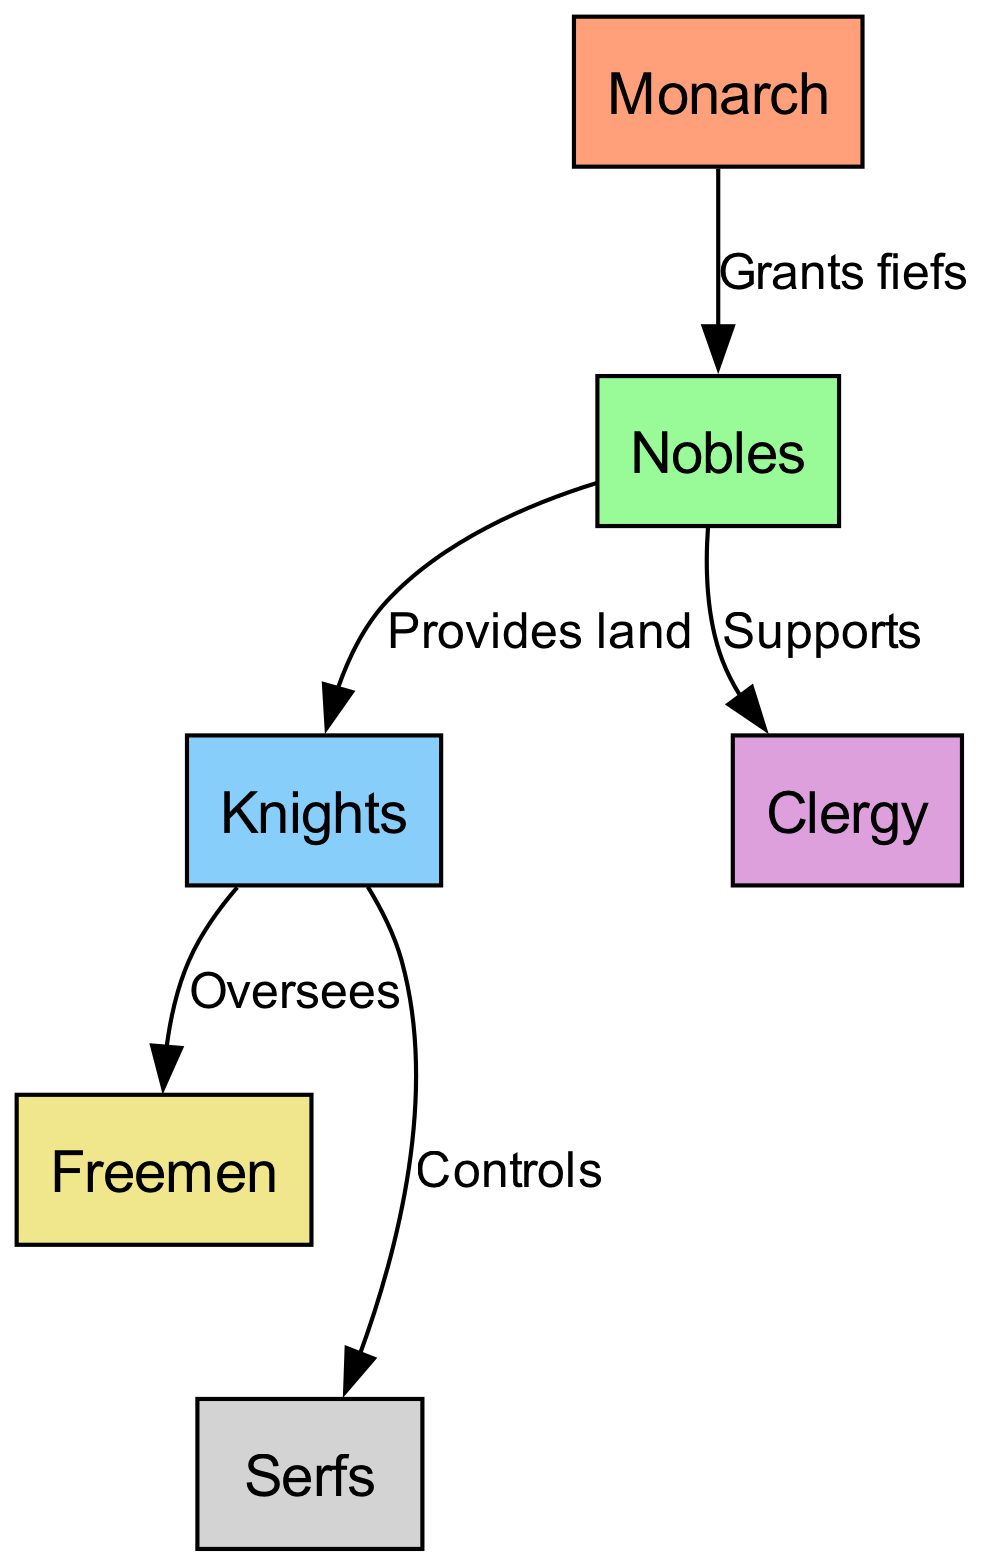What is the top node in the feudal system? The top node is the Monarch as it is the highest authority in the hierarchical structure of the feudal system.
Answer: Monarch How many total nodes are present in the diagram? There are six nodes representing different levels of the feudal system: Monarch, Nobles, Knights, Clergy, Freemen, and Serfs.
Answer: 6 What role do Nobles play towards Knights? Nobles provide land to Knights, which is a crucial relationship in the feudal system as it enables Knights to serve their feudal lords.
Answer: Provides land Who directly controls the Serfs? Knights directly control the Serfs, as depicted by the edge connecting the Knights node to the Serfs node labeled "Controls".
Answer: Knights Which group does the Monarch grant fiefs to? The Monarch grants fiefs to the Nobles, which signifies the distribution of land within the feudal hierarchy.
Answer: Nobles How many edges are there in total in this diagram? The diagram contains five edges that represent the relationships between different nodes in the feudal system.
Answer: 5 What support do Nobles give to Clergy? Nobles support the Clergy, which indicates a relationship of assistance and possibly financial backing in the feudal system.
Answer: Supports Which group oversees the Freemen? Knights oversee the Freemen, as represented by the edge from Knights to Freemen labeled "Oversees".
Answer: Knights What is the relationship between Nobles and Clergy? Nobles support the Clergy, highlighting the important connection between secular and religious authority within the feudal society.
Answer: Supports 